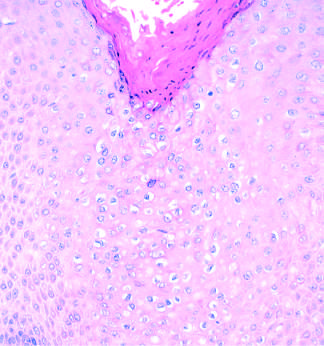do histopathologic features of condyloma acuminatum include acanthosis, hyperkeratosis, and cytoplasmic vacuolization?
Answer the question using a single word or phrase. Yes 